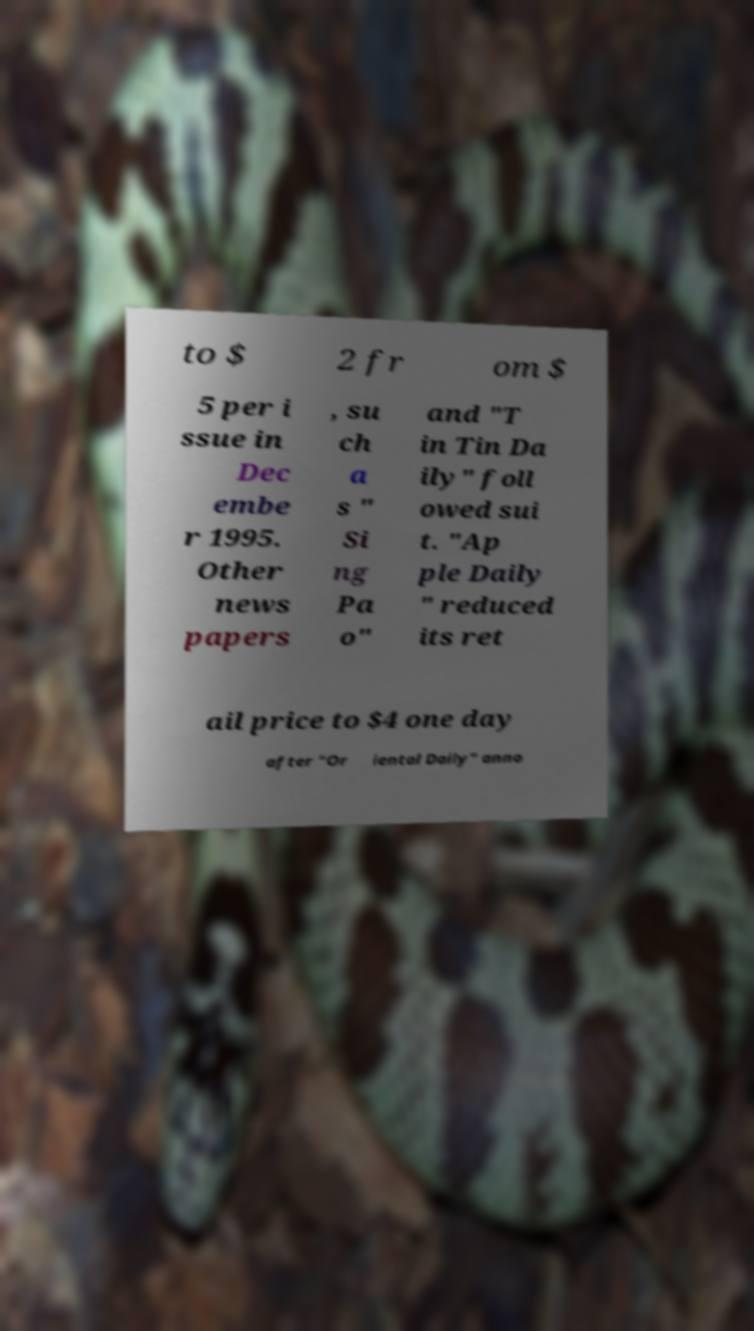Can you accurately transcribe the text from the provided image for me? to $ 2 fr om $ 5 per i ssue in Dec embe r 1995. Other news papers , su ch a s " Si ng Pa o" and "T in Tin Da ily" foll owed sui t. "Ap ple Daily " reduced its ret ail price to $4 one day after "Or iental Daily" anno 